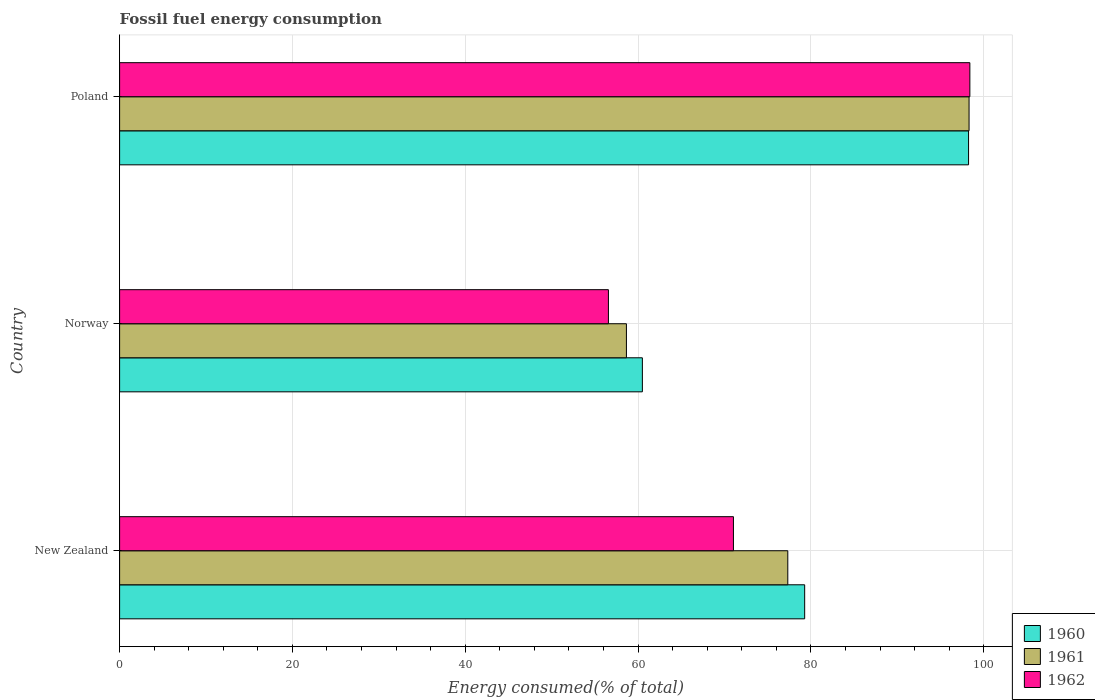How many different coloured bars are there?
Your answer should be very brief. 3. Are the number of bars per tick equal to the number of legend labels?
Your response must be concise. Yes. What is the label of the 2nd group of bars from the top?
Keep it short and to the point. Norway. In how many cases, is the number of bars for a given country not equal to the number of legend labels?
Offer a terse response. 0. What is the percentage of energy consumed in 1961 in New Zealand?
Offer a terse response. 77.33. Across all countries, what is the maximum percentage of energy consumed in 1960?
Ensure brevity in your answer.  98.25. Across all countries, what is the minimum percentage of energy consumed in 1960?
Make the answer very short. 60.5. In which country was the percentage of energy consumed in 1960 minimum?
Provide a succinct answer. Norway. What is the total percentage of energy consumed in 1961 in the graph?
Your response must be concise. 234.28. What is the difference between the percentage of energy consumed in 1960 in Norway and that in Poland?
Ensure brevity in your answer.  -37.75. What is the difference between the percentage of energy consumed in 1962 in Poland and the percentage of energy consumed in 1961 in New Zealand?
Your answer should be compact. 21.07. What is the average percentage of energy consumed in 1962 per country?
Your response must be concise. 75.33. What is the difference between the percentage of energy consumed in 1962 and percentage of energy consumed in 1961 in Poland?
Keep it short and to the point. 0.09. In how many countries, is the percentage of energy consumed in 1961 greater than 92 %?
Make the answer very short. 1. What is the ratio of the percentage of energy consumed in 1961 in New Zealand to that in Poland?
Offer a very short reply. 0.79. Is the percentage of energy consumed in 1960 in New Zealand less than that in Norway?
Provide a short and direct response. No. Is the difference between the percentage of energy consumed in 1962 in New Zealand and Poland greater than the difference between the percentage of energy consumed in 1961 in New Zealand and Poland?
Make the answer very short. No. What is the difference between the highest and the second highest percentage of energy consumed in 1962?
Your response must be concise. 27.36. What is the difference between the highest and the lowest percentage of energy consumed in 1960?
Make the answer very short. 37.75. How many countries are there in the graph?
Ensure brevity in your answer.  3. Are the values on the major ticks of X-axis written in scientific E-notation?
Your response must be concise. No. Does the graph contain any zero values?
Your answer should be compact. No. Does the graph contain grids?
Your response must be concise. Yes. Where does the legend appear in the graph?
Give a very brief answer. Bottom right. What is the title of the graph?
Your answer should be compact. Fossil fuel energy consumption. Does "2003" appear as one of the legend labels in the graph?
Your answer should be compact. No. What is the label or title of the X-axis?
Provide a succinct answer. Energy consumed(% of total). What is the label or title of the Y-axis?
Provide a succinct answer. Country. What is the Energy consumed(% of total) of 1960 in New Zealand?
Keep it short and to the point. 79.28. What is the Energy consumed(% of total) in 1961 in New Zealand?
Your answer should be compact. 77.33. What is the Energy consumed(% of total) of 1962 in New Zealand?
Your answer should be very brief. 71.04. What is the Energy consumed(% of total) in 1960 in Norway?
Keep it short and to the point. 60.5. What is the Energy consumed(% of total) in 1961 in Norway?
Your answer should be very brief. 58.65. What is the Energy consumed(% of total) in 1962 in Norway?
Provide a short and direct response. 56.57. What is the Energy consumed(% of total) in 1960 in Poland?
Provide a succinct answer. 98.25. What is the Energy consumed(% of total) in 1961 in Poland?
Your answer should be compact. 98.3. What is the Energy consumed(% of total) of 1962 in Poland?
Your answer should be very brief. 98.4. Across all countries, what is the maximum Energy consumed(% of total) in 1960?
Ensure brevity in your answer.  98.25. Across all countries, what is the maximum Energy consumed(% of total) of 1961?
Your answer should be compact. 98.3. Across all countries, what is the maximum Energy consumed(% of total) of 1962?
Your response must be concise. 98.4. Across all countries, what is the minimum Energy consumed(% of total) of 1960?
Provide a succinct answer. 60.5. Across all countries, what is the minimum Energy consumed(% of total) of 1961?
Your answer should be compact. 58.65. Across all countries, what is the minimum Energy consumed(% of total) in 1962?
Keep it short and to the point. 56.57. What is the total Energy consumed(% of total) in 1960 in the graph?
Provide a short and direct response. 238.02. What is the total Energy consumed(% of total) of 1961 in the graph?
Your answer should be compact. 234.28. What is the total Energy consumed(% of total) in 1962 in the graph?
Provide a succinct answer. 226. What is the difference between the Energy consumed(% of total) of 1960 in New Zealand and that in Norway?
Provide a succinct answer. 18.78. What is the difference between the Energy consumed(% of total) in 1961 in New Zealand and that in Norway?
Ensure brevity in your answer.  18.68. What is the difference between the Energy consumed(% of total) in 1962 in New Zealand and that in Norway?
Your response must be concise. 14.47. What is the difference between the Energy consumed(% of total) of 1960 in New Zealand and that in Poland?
Make the answer very short. -18.97. What is the difference between the Energy consumed(% of total) in 1961 in New Zealand and that in Poland?
Your answer should be very brief. -20.98. What is the difference between the Energy consumed(% of total) of 1962 in New Zealand and that in Poland?
Your answer should be very brief. -27.36. What is the difference between the Energy consumed(% of total) in 1960 in Norway and that in Poland?
Make the answer very short. -37.75. What is the difference between the Energy consumed(% of total) of 1961 in Norway and that in Poland?
Your answer should be very brief. -39.65. What is the difference between the Energy consumed(% of total) in 1962 in Norway and that in Poland?
Make the answer very short. -41.83. What is the difference between the Energy consumed(% of total) in 1960 in New Zealand and the Energy consumed(% of total) in 1961 in Norway?
Your answer should be compact. 20.63. What is the difference between the Energy consumed(% of total) of 1960 in New Zealand and the Energy consumed(% of total) of 1962 in Norway?
Offer a terse response. 22.71. What is the difference between the Energy consumed(% of total) of 1961 in New Zealand and the Energy consumed(% of total) of 1962 in Norway?
Provide a short and direct response. 20.76. What is the difference between the Energy consumed(% of total) of 1960 in New Zealand and the Energy consumed(% of total) of 1961 in Poland?
Your answer should be compact. -19.02. What is the difference between the Energy consumed(% of total) of 1960 in New Zealand and the Energy consumed(% of total) of 1962 in Poland?
Provide a succinct answer. -19.12. What is the difference between the Energy consumed(% of total) of 1961 in New Zealand and the Energy consumed(% of total) of 1962 in Poland?
Your response must be concise. -21.07. What is the difference between the Energy consumed(% of total) of 1960 in Norway and the Energy consumed(% of total) of 1961 in Poland?
Make the answer very short. -37.81. What is the difference between the Energy consumed(% of total) of 1960 in Norway and the Energy consumed(% of total) of 1962 in Poland?
Give a very brief answer. -37.9. What is the difference between the Energy consumed(% of total) of 1961 in Norway and the Energy consumed(% of total) of 1962 in Poland?
Provide a succinct answer. -39.74. What is the average Energy consumed(% of total) in 1960 per country?
Keep it short and to the point. 79.34. What is the average Energy consumed(% of total) in 1961 per country?
Provide a short and direct response. 78.09. What is the average Energy consumed(% of total) of 1962 per country?
Provide a succinct answer. 75.33. What is the difference between the Energy consumed(% of total) of 1960 and Energy consumed(% of total) of 1961 in New Zealand?
Ensure brevity in your answer.  1.95. What is the difference between the Energy consumed(% of total) of 1960 and Energy consumed(% of total) of 1962 in New Zealand?
Provide a succinct answer. 8.24. What is the difference between the Energy consumed(% of total) in 1961 and Energy consumed(% of total) in 1962 in New Zealand?
Provide a succinct answer. 6.29. What is the difference between the Energy consumed(% of total) in 1960 and Energy consumed(% of total) in 1961 in Norway?
Your response must be concise. 1.85. What is the difference between the Energy consumed(% of total) of 1960 and Energy consumed(% of total) of 1962 in Norway?
Provide a succinct answer. 3.93. What is the difference between the Energy consumed(% of total) of 1961 and Energy consumed(% of total) of 1962 in Norway?
Your answer should be very brief. 2.08. What is the difference between the Energy consumed(% of total) of 1960 and Energy consumed(% of total) of 1961 in Poland?
Provide a succinct answer. -0.06. What is the difference between the Energy consumed(% of total) of 1960 and Energy consumed(% of total) of 1962 in Poland?
Your answer should be compact. -0.15. What is the difference between the Energy consumed(% of total) in 1961 and Energy consumed(% of total) in 1962 in Poland?
Your response must be concise. -0.09. What is the ratio of the Energy consumed(% of total) in 1960 in New Zealand to that in Norway?
Offer a very short reply. 1.31. What is the ratio of the Energy consumed(% of total) in 1961 in New Zealand to that in Norway?
Make the answer very short. 1.32. What is the ratio of the Energy consumed(% of total) of 1962 in New Zealand to that in Norway?
Make the answer very short. 1.26. What is the ratio of the Energy consumed(% of total) in 1960 in New Zealand to that in Poland?
Your answer should be compact. 0.81. What is the ratio of the Energy consumed(% of total) of 1961 in New Zealand to that in Poland?
Provide a succinct answer. 0.79. What is the ratio of the Energy consumed(% of total) of 1962 in New Zealand to that in Poland?
Your answer should be compact. 0.72. What is the ratio of the Energy consumed(% of total) of 1960 in Norway to that in Poland?
Give a very brief answer. 0.62. What is the ratio of the Energy consumed(% of total) in 1961 in Norway to that in Poland?
Keep it short and to the point. 0.6. What is the ratio of the Energy consumed(% of total) in 1962 in Norway to that in Poland?
Offer a very short reply. 0.57. What is the difference between the highest and the second highest Energy consumed(% of total) in 1960?
Your answer should be compact. 18.97. What is the difference between the highest and the second highest Energy consumed(% of total) in 1961?
Your answer should be very brief. 20.98. What is the difference between the highest and the second highest Energy consumed(% of total) of 1962?
Make the answer very short. 27.36. What is the difference between the highest and the lowest Energy consumed(% of total) in 1960?
Give a very brief answer. 37.75. What is the difference between the highest and the lowest Energy consumed(% of total) in 1961?
Provide a short and direct response. 39.65. What is the difference between the highest and the lowest Energy consumed(% of total) in 1962?
Offer a very short reply. 41.83. 